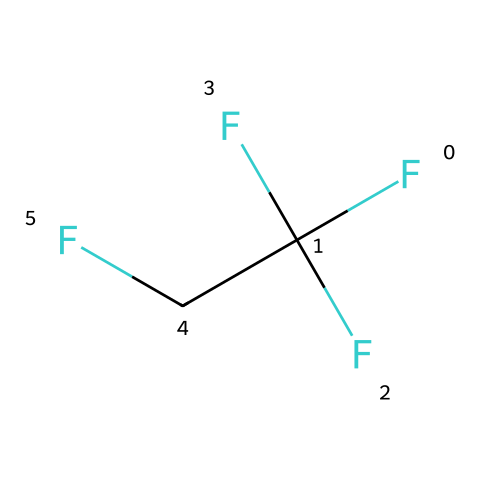What is the molecular formula of R-134a? The SMILES notation indicates the number of atoms present. In the structure FC(F)(F)CF, there are 2 carbon (C) atoms, 1 hydrogen (H) atom, and 4 fluorine (F) atoms. Therefore, the molecular formula can be written as C2H2F4.
Answer: C2H2F4 How many carbon atoms are in the chemical structure of R-134a? By analyzing the SMILES notation, we see that there are two carbon (C) atoms present in the formula FC(F)(F)CF. Each "C" corresponds to a carbon atom in the structure.
Answer: 2 What type of refrigerant is R-134a classified as? R-134a is classified as a hydrofluorocarbon (HFC) due to its chemical composition that includes hydrogen, fluorine, and carbon. This classification is critical for identifying its uses in refrigeration.
Answer: hydrofluorocarbon What is the total number of fluorine atoms in R-134a? In the SMILES representation, FC(F)(F)CF includes three instances of 'F', indicating that there are a total of four fluorine (F) atoms in the chemical structure.
Answer: 4 Which functional group characterizes R-134a as a refrigerant? The presence of fluorine atoms is crucial for its classification as a refrigerant, as they influence the compound's stability and efficiency. Therefore, the incorporation of multiple fluorine atoms indicates its functionality as a refrigerant.
Answer: fluorine What is the boiling point range of R-134a based on its structure? R-134a has a typical boiling point around -26 to -24 degrees Celsius. This low boiling point allows for effective cooling applications in air conditioning systems.
Answer: -26 to -24 degrees Celsius Does R-134a contribute to ozone depletion? R-134a is categorized as a non-ozone-depleting substance compared to chlorofluorocarbons (CFCs), as indicated by its structure which does not contain chlorine atoms. Thus, it does not pose a significant risk to the ozone layer.
Answer: no 